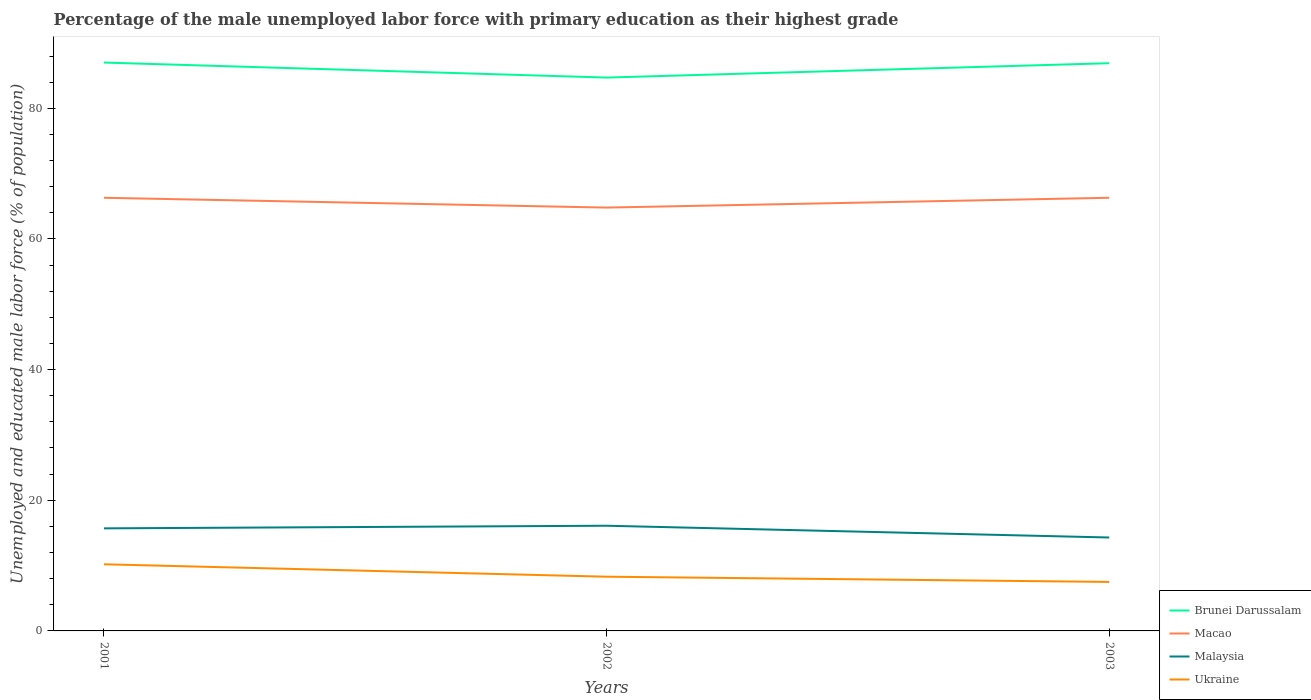Does the line corresponding to Ukraine intersect with the line corresponding to Malaysia?
Keep it short and to the point. No. Across all years, what is the maximum percentage of the unemployed male labor force with primary education in Malaysia?
Ensure brevity in your answer.  14.3. What is the total percentage of the unemployed male labor force with primary education in Malaysia in the graph?
Ensure brevity in your answer.  1.8. What is the difference between the highest and the second highest percentage of the unemployed male labor force with primary education in Macao?
Offer a very short reply. 1.5. How many lines are there?
Ensure brevity in your answer.  4. How many years are there in the graph?
Ensure brevity in your answer.  3. What is the difference between two consecutive major ticks on the Y-axis?
Offer a terse response. 20. Are the values on the major ticks of Y-axis written in scientific E-notation?
Give a very brief answer. No. How many legend labels are there?
Ensure brevity in your answer.  4. How are the legend labels stacked?
Your answer should be very brief. Vertical. What is the title of the graph?
Offer a very short reply. Percentage of the male unemployed labor force with primary education as their highest grade. Does "Caribbean small states" appear as one of the legend labels in the graph?
Your answer should be very brief. No. What is the label or title of the Y-axis?
Keep it short and to the point. Unemployed and educated male labor force (% of population). What is the Unemployed and educated male labor force (% of population) in Brunei Darussalam in 2001?
Give a very brief answer. 87. What is the Unemployed and educated male labor force (% of population) of Macao in 2001?
Provide a succinct answer. 66.3. What is the Unemployed and educated male labor force (% of population) in Malaysia in 2001?
Offer a very short reply. 15.7. What is the Unemployed and educated male labor force (% of population) in Ukraine in 2001?
Provide a short and direct response. 10.2. What is the Unemployed and educated male labor force (% of population) in Brunei Darussalam in 2002?
Provide a succinct answer. 84.7. What is the Unemployed and educated male labor force (% of population) of Macao in 2002?
Make the answer very short. 64.8. What is the Unemployed and educated male labor force (% of population) in Malaysia in 2002?
Provide a short and direct response. 16.1. What is the Unemployed and educated male labor force (% of population) in Ukraine in 2002?
Make the answer very short. 8.3. What is the Unemployed and educated male labor force (% of population) in Brunei Darussalam in 2003?
Give a very brief answer. 86.9. What is the Unemployed and educated male labor force (% of population) in Macao in 2003?
Your answer should be very brief. 66.3. What is the Unemployed and educated male labor force (% of population) of Malaysia in 2003?
Give a very brief answer. 14.3. Across all years, what is the maximum Unemployed and educated male labor force (% of population) of Macao?
Give a very brief answer. 66.3. Across all years, what is the maximum Unemployed and educated male labor force (% of population) of Malaysia?
Offer a very short reply. 16.1. Across all years, what is the maximum Unemployed and educated male labor force (% of population) of Ukraine?
Your answer should be very brief. 10.2. Across all years, what is the minimum Unemployed and educated male labor force (% of population) in Brunei Darussalam?
Keep it short and to the point. 84.7. Across all years, what is the minimum Unemployed and educated male labor force (% of population) in Macao?
Provide a succinct answer. 64.8. Across all years, what is the minimum Unemployed and educated male labor force (% of population) of Malaysia?
Offer a terse response. 14.3. Across all years, what is the minimum Unemployed and educated male labor force (% of population) in Ukraine?
Offer a very short reply. 7.5. What is the total Unemployed and educated male labor force (% of population) of Brunei Darussalam in the graph?
Provide a short and direct response. 258.6. What is the total Unemployed and educated male labor force (% of population) in Macao in the graph?
Provide a short and direct response. 197.4. What is the total Unemployed and educated male labor force (% of population) of Malaysia in the graph?
Offer a terse response. 46.1. What is the total Unemployed and educated male labor force (% of population) of Ukraine in the graph?
Provide a succinct answer. 26. What is the difference between the Unemployed and educated male labor force (% of population) in Brunei Darussalam in 2001 and that in 2002?
Your response must be concise. 2.3. What is the difference between the Unemployed and educated male labor force (% of population) of Brunei Darussalam in 2001 and that in 2003?
Your answer should be very brief. 0.1. What is the difference between the Unemployed and educated male labor force (% of population) of Malaysia in 2001 and that in 2003?
Provide a short and direct response. 1.4. What is the difference between the Unemployed and educated male labor force (% of population) of Brunei Darussalam in 2002 and that in 2003?
Offer a terse response. -2.2. What is the difference between the Unemployed and educated male labor force (% of population) in Malaysia in 2002 and that in 2003?
Your answer should be very brief. 1.8. What is the difference between the Unemployed and educated male labor force (% of population) in Ukraine in 2002 and that in 2003?
Your answer should be compact. 0.8. What is the difference between the Unemployed and educated male labor force (% of population) in Brunei Darussalam in 2001 and the Unemployed and educated male labor force (% of population) in Macao in 2002?
Make the answer very short. 22.2. What is the difference between the Unemployed and educated male labor force (% of population) of Brunei Darussalam in 2001 and the Unemployed and educated male labor force (% of population) of Malaysia in 2002?
Provide a short and direct response. 70.9. What is the difference between the Unemployed and educated male labor force (% of population) of Brunei Darussalam in 2001 and the Unemployed and educated male labor force (% of population) of Ukraine in 2002?
Keep it short and to the point. 78.7. What is the difference between the Unemployed and educated male labor force (% of population) of Macao in 2001 and the Unemployed and educated male labor force (% of population) of Malaysia in 2002?
Your response must be concise. 50.2. What is the difference between the Unemployed and educated male labor force (% of population) of Malaysia in 2001 and the Unemployed and educated male labor force (% of population) of Ukraine in 2002?
Keep it short and to the point. 7.4. What is the difference between the Unemployed and educated male labor force (% of population) in Brunei Darussalam in 2001 and the Unemployed and educated male labor force (% of population) in Macao in 2003?
Make the answer very short. 20.7. What is the difference between the Unemployed and educated male labor force (% of population) of Brunei Darussalam in 2001 and the Unemployed and educated male labor force (% of population) of Malaysia in 2003?
Offer a terse response. 72.7. What is the difference between the Unemployed and educated male labor force (% of population) in Brunei Darussalam in 2001 and the Unemployed and educated male labor force (% of population) in Ukraine in 2003?
Give a very brief answer. 79.5. What is the difference between the Unemployed and educated male labor force (% of population) in Macao in 2001 and the Unemployed and educated male labor force (% of population) in Malaysia in 2003?
Offer a very short reply. 52. What is the difference between the Unemployed and educated male labor force (% of population) of Macao in 2001 and the Unemployed and educated male labor force (% of population) of Ukraine in 2003?
Your answer should be compact. 58.8. What is the difference between the Unemployed and educated male labor force (% of population) of Malaysia in 2001 and the Unemployed and educated male labor force (% of population) of Ukraine in 2003?
Make the answer very short. 8.2. What is the difference between the Unemployed and educated male labor force (% of population) in Brunei Darussalam in 2002 and the Unemployed and educated male labor force (% of population) in Malaysia in 2003?
Your answer should be very brief. 70.4. What is the difference between the Unemployed and educated male labor force (% of population) of Brunei Darussalam in 2002 and the Unemployed and educated male labor force (% of population) of Ukraine in 2003?
Offer a very short reply. 77.2. What is the difference between the Unemployed and educated male labor force (% of population) in Macao in 2002 and the Unemployed and educated male labor force (% of population) in Malaysia in 2003?
Provide a succinct answer. 50.5. What is the difference between the Unemployed and educated male labor force (% of population) in Macao in 2002 and the Unemployed and educated male labor force (% of population) in Ukraine in 2003?
Make the answer very short. 57.3. What is the difference between the Unemployed and educated male labor force (% of population) of Malaysia in 2002 and the Unemployed and educated male labor force (% of population) of Ukraine in 2003?
Your answer should be very brief. 8.6. What is the average Unemployed and educated male labor force (% of population) of Brunei Darussalam per year?
Give a very brief answer. 86.2. What is the average Unemployed and educated male labor force (% of population) of Macao per year?
Make the answer very short. 65.8. What is the average Unemployed and educated male labor force (% of population) in Malaysia per year?
Keep it short and to the point. 15.37. What is the average Unemployed and educated male labor force (% of population) of Ukraine per year?
Offer a terse response. 8.67. In the year 2001, what is the difference between the Unemployed and educated male labor force (% of population) of Brunei Darussalam and Unemployed and educated male labor force (% of population) of Macao?
Provide a succinct answer. 20.7. In the year 2001, what is the difference between the Unemployed and educated male labor force (% of population) in Brunei Darussalam and Unemployed and educated male labor force (% of population) in Malaysia?
Ensure brevity in your answer.  71.3. In the year 2001, what is the difference between the Unemployed and educated male labor force (% of population) of Brunei Darussalam and Unemployed and educated male labor force (% of population) of Ukraine?
Provide a short and direct response. 76.8. In the year 2001, what is the difference between the Unemployed and educated male labor force (% of population) of Macao and Unemployed and educated male labor force (% of population) of Malaysia?
Ensure brevity in your answer.  50.6. In the year 2001, what is the difference between the Unemployed and educated male labor force (% of population) of Macao and Unemployed and educated male labor force (% of population) of Ukraine?
Make the answer very short. 56.1. In the year 2001, what is the difference between the Unemployed and educated male labor force (% of population) of Malaysia and Unemployed and educated male labor force (% of population) of Ukraine?
Give a very brief answer. 5.5. In the year 2002, what is the difference between the Unemployed and educated male labor force (% of population) in Brunei Darussalam and Unemployed and educated male labor force (% of population) in Macao?
Your answer should be very brief. 19.9. In the year 2002, what is the difference between the Unemployed and educated male labor force (% of population) of Brunei Darussalam and Unemployed and educated male labor force (% of population) of Malaysia?
Give a very brief answer. 68.6. In the year 2002, what is the difference between the Unemployed and educated male labor force (% of population) of Brunei Darussalam and Unemployed and educated male labor force (% of population) of Ukraine?
Give a very brief answer. 76.4. In the year 2002, what is the difference between the Unemployed and educated male labor force (% of population) of Macao and Unemployed and educated male labor force (% of population) of Malaysia?
Your response must be concise. 48.7. In the year 2002, what is the difference between the Unemployed and educated male labor force (% of population) in Macao and Unemployed and educated male labor force (% of population) in Ukraine?
Your answer should be compact. 56.5. In the year 2002, what is the difference between the Unemployed and educated male labor force (% of population) of Malaysia and Unemployed and educated male labor force (% of population) of Ukraine?
Ensure brevity in your answer.  7.8. In the year 2003, what is the difference between the Unemployed and educated male labor force (% of population) in Brunei Darussalam and Unemployed and educated male labor force (% of population) in Macao?
Offer a terse response. 20.6. In the year 2003, what is the difference between the Unemployed and educated male labor force (% of population) of Brunei Darussalam and Unemployed and educated male labor force (% of population) of Malaysia?
Make the answer very short. 72.6. In the year 2003, what is the difference between the Unemployed and educated male labor force (% of population) of Brunei Darussalam and Unemployed and educated male labor force (% of population) of Ukraine?
Ensure brevity in your answer.  79.4. In the year 2003, what is the difference between the Unemployed and educated male labor force (% of population) in Macao and Unemployed and educated male labor force (% of population) in Malaysia?
Provide a short and direct response. 52. In the year 2003, what is the difference between the Unemployed and educated male labor force (% of population) in Macao and Unemployed and educated male labor force (% of population) in Ukraine?
Ensure brevity in your answer.  58.8. In the year 2003, what is the difference between the Unemployed and educated male labor force (% of population) in Malaysia and Unemployed and educated male labor force (% of population) in Ukraine?
Give a very brief answer. 6.8. What is the ratio of the Unemployed and educated male labor force (% of population) in Brunei Darussalam in 2001 to that in 2002?
Your answer should be compact. 1.03. What is the ratio of the Unemployed and educated male labor force (% of population) in Macao in 2001 to that in 2002?
Ensure brevity in your answer.  1.02. What is the ratio of the Unemployed and educated male labor force (% of population) of Malaysia in 2001 to that in 2002?
Provide a succinct answer. 0.98. What is the ratio of the Unemployed and educated male labor force (% of population) in Ukraine in 2001 to that in 2002?
Your answer should be very brief. 1.23. What is the ratio of the Unemployed and educated male labor force (% of population) in Brunei Darussalam in 2001 to that in 2003?
Offer a terse response. 1. What is the ratio of the Unemployed and educated male labor force (% of population) in Macao in 2001 to that in 2003?
Your answer should be very brief. 1. What is the ratio of the Unemployed and educated male labor force (% of population) in Malaysia in 2001 to that in 2003?
Ensure brevity in your answer.  1.1. What is the ratio of the Unemployed and educated male labor force (% of population) of Ukraine in 2001 to that in 2003?
Ensure brevity in your answer.  1.36. What is the ratio of the Unemployed and educated male labor force (% of population) in Brunei Darussalam in 2002 to that in 2003?
Your answer should be compact. 0.97. What is the ratio of the Unemployed and educated male labor force (% of population) in Macao in 2002 to that in 2003?
Your answer should be very brief. 0.98. What is the ratio of the Unemployed and educated male labor force (% of population) of Malaysia in 2002 to that in 2003?
Ensure brevity in your answer.  1.13. What is the ratio of the Unemployed and educated male labor force (% of population) in Ukraine in 2002 to that in 2003?
Ensure brevity in your answer.  1.11. What is the difference between the highest and the second highest Unemployed and educated male labor force (% of population) of Brunei Darussalam?
Make the answer very short. 0.1. What is the difference between the highest and the second highest Unemployed and educated male labor force (% of population) of Malaysia?
Ensure brevity in your answer.  0.4. What is the difference between the highest and the second highest Unemployed and educated male labor force (% of population) of Ukraine?
Offer a very short reply. 1.9. What is the difference between the highest and the lowest Unemployed and educated male labor force (% of population) of Brunei Darussalam?
Your response must be concise. 2.3. What is the difference between the highest and the lowest Unemployed and educated male labor force (% of population) of Malaysia?
Ensure brevity in your answer.  1.8. What is the difference between the highest and the lowest Unemployed and educated male labor force (% of population) of Ukraine?
Keep it short and to the point. 2.7. 